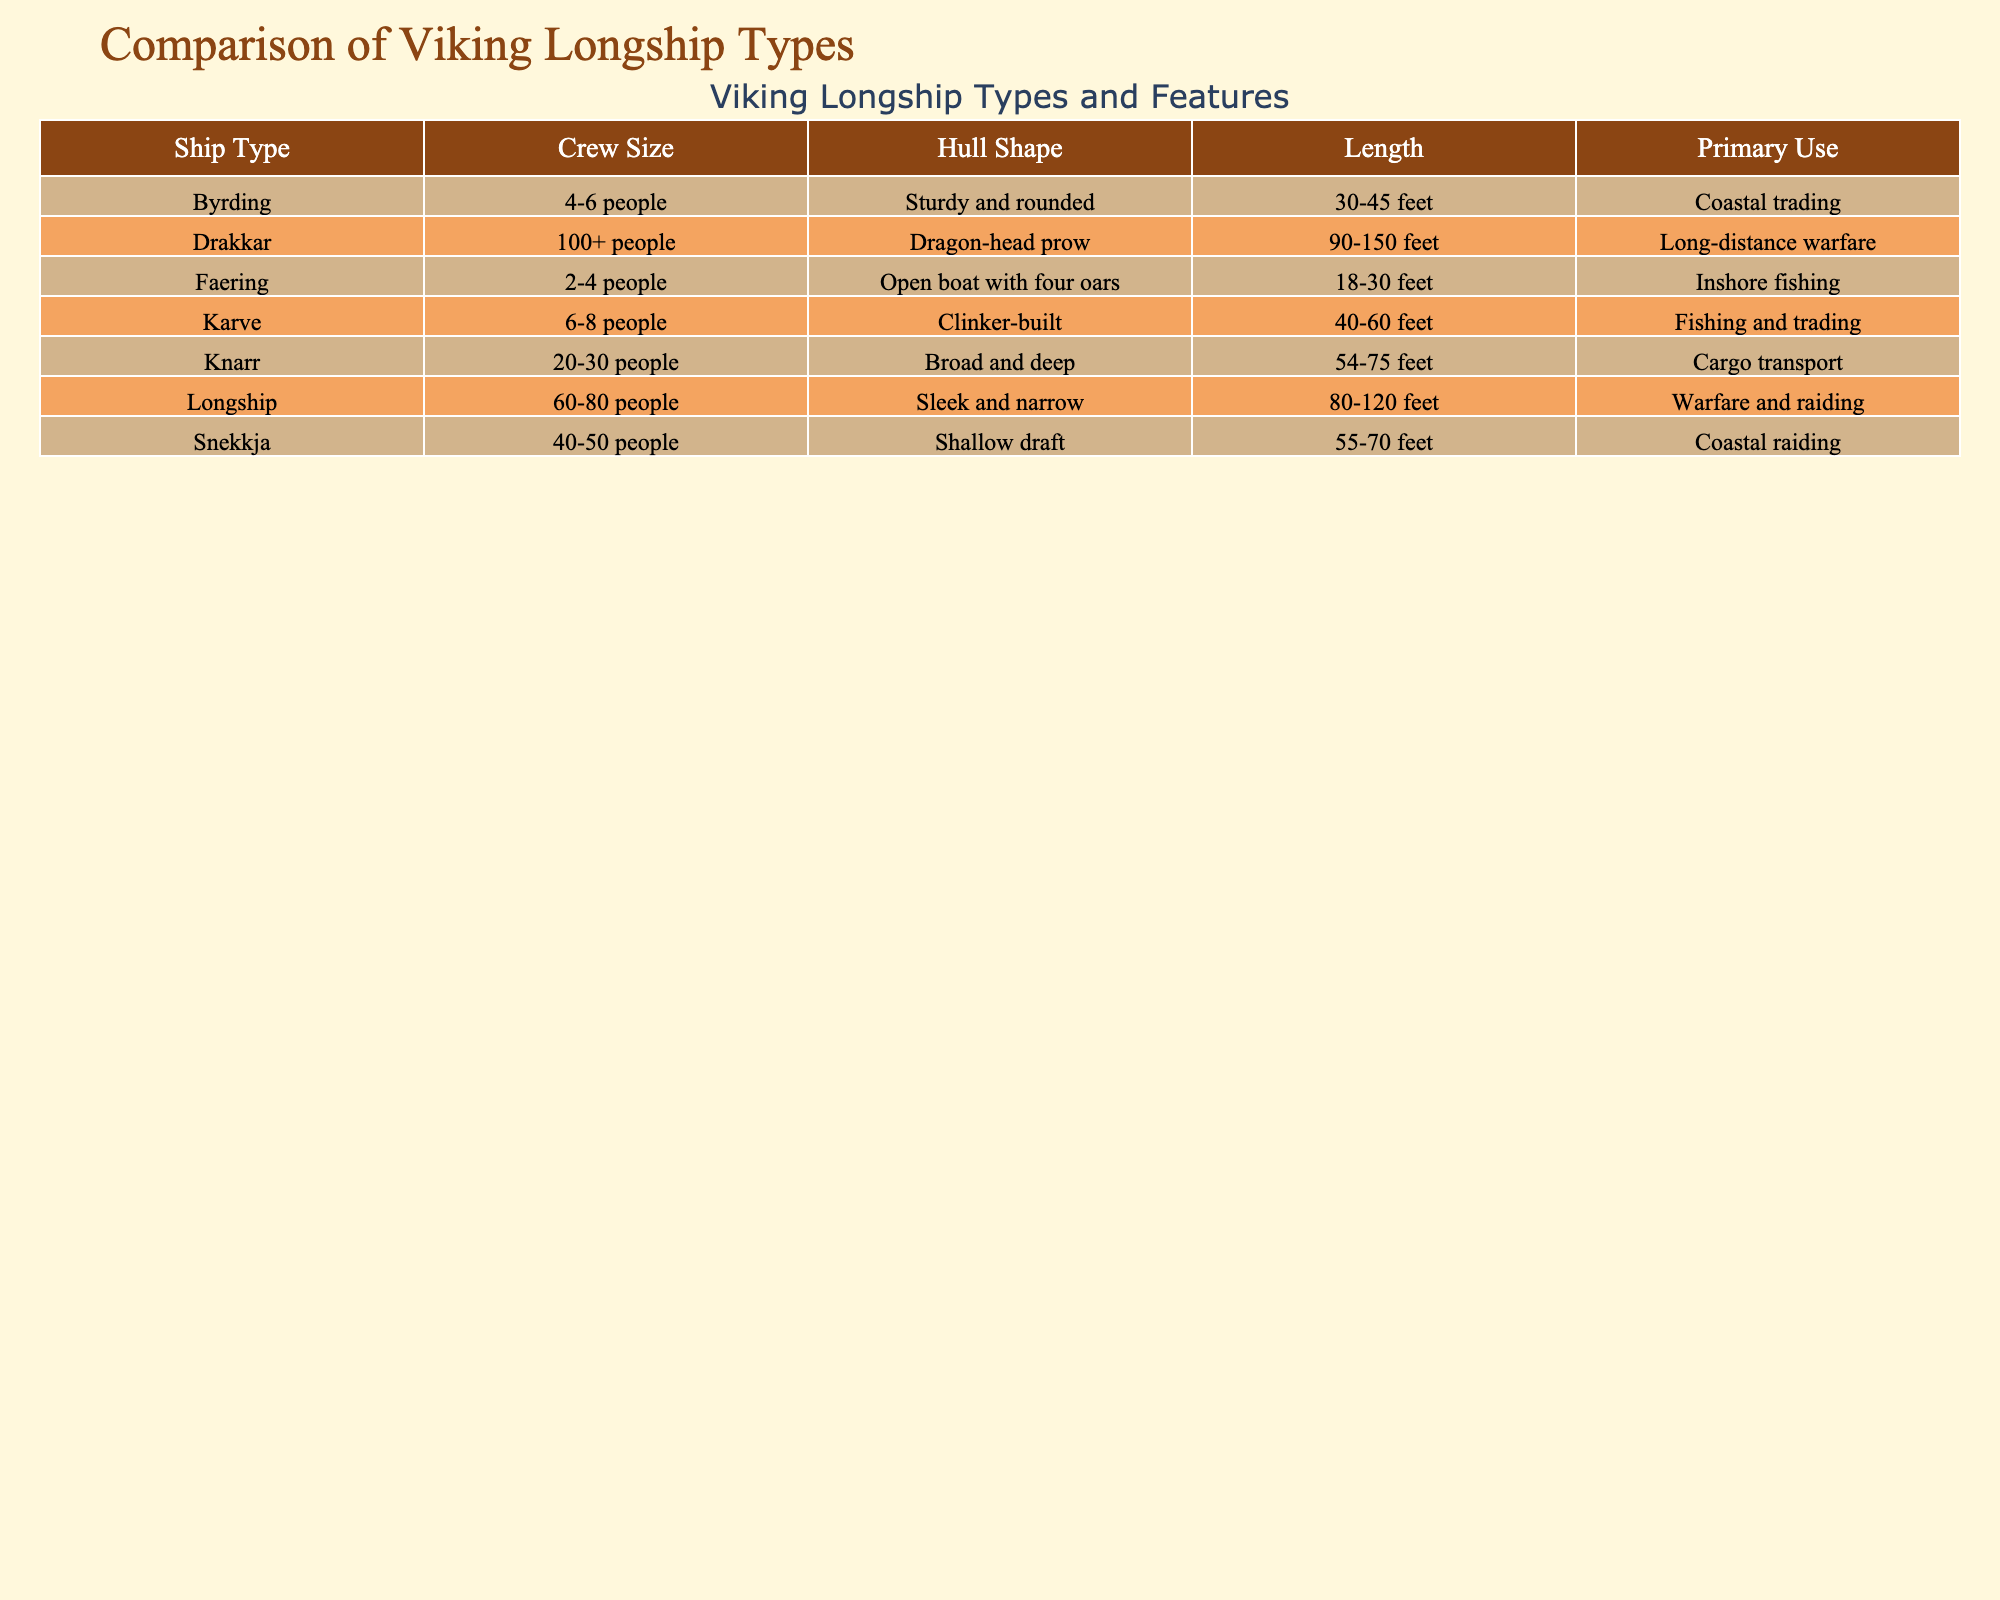What is the length range of a Knarr? The table shows that the length of a Knarr falls between 54 and 75 feet.
Answer: 54-75 feet How many crew members does a Longship require? According to the table, a Longship needs a crew of 60 to 80 people.
Answer: 60-80 people What is the primary use of a Faering? The table indicates that a Faering is primarily used for inshore fishing.
Answer: Inshore fishing Which ship type has the largest length range? By comparing the lengths in the table, the Drakkar, which ranges from 90 to 150 feet, has the largest range.
Answer: Drakkar Is the hull shape of the Karve clinker-built? Yes, the table confirms that the Karve has a clinker-built hull shape.
Answer: Yes What is the average crew size of all ship types listed? Summing the crew sizes provides: (7 + 25 + 70 + 45 + 100 + 5 + 3)/7 = 50. This yields an average crew size of 50.
Answer: 50 Which ship type is mainly used for cargo transport? The table specifies that Knarr is the ship type primarily used for cargo transport.
Answer: Knarr How does the length of a Byrding compare to a Longship? A Byrding is shorter, with a maximum length of 45 feet compared to 120 feet for a Longship, making it significantly smaller.
Answer: Shorter What hull shape is associated with a Snekkja? The Snekkja has a shallow draft hull shape as stated in the table.
Answer: Shallow draft Which ship type requires the least number of crew members? The Faering requires the least crew, needing only 2 to 4 people based on the table data.
Answer: Faering 